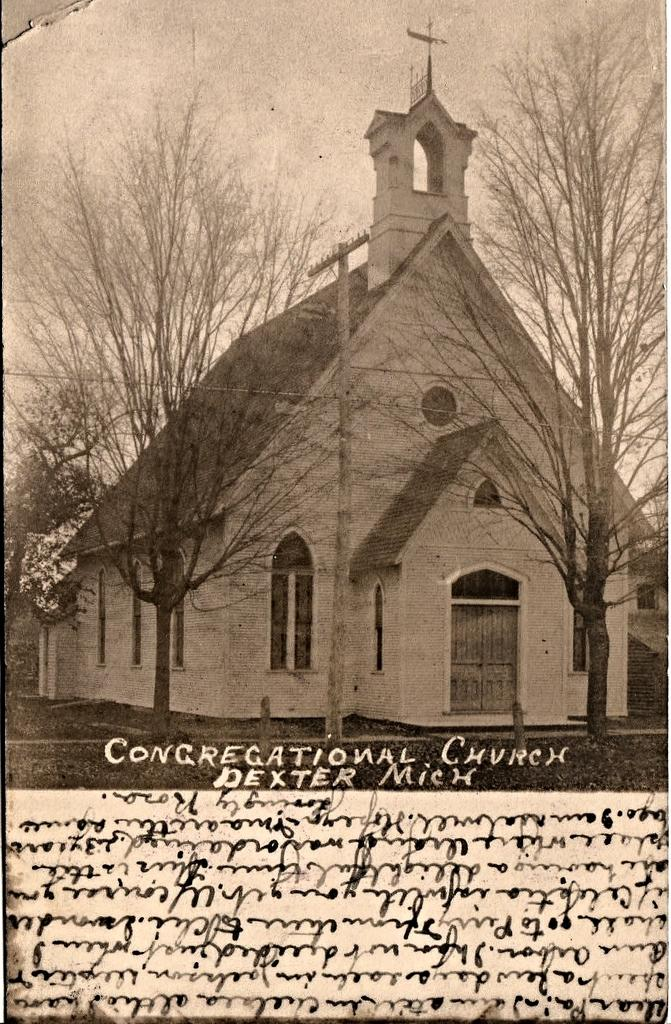<image>
Provide a brief description of the given image. Vintage photo of the Congregational Church in Dixter Michigan. 